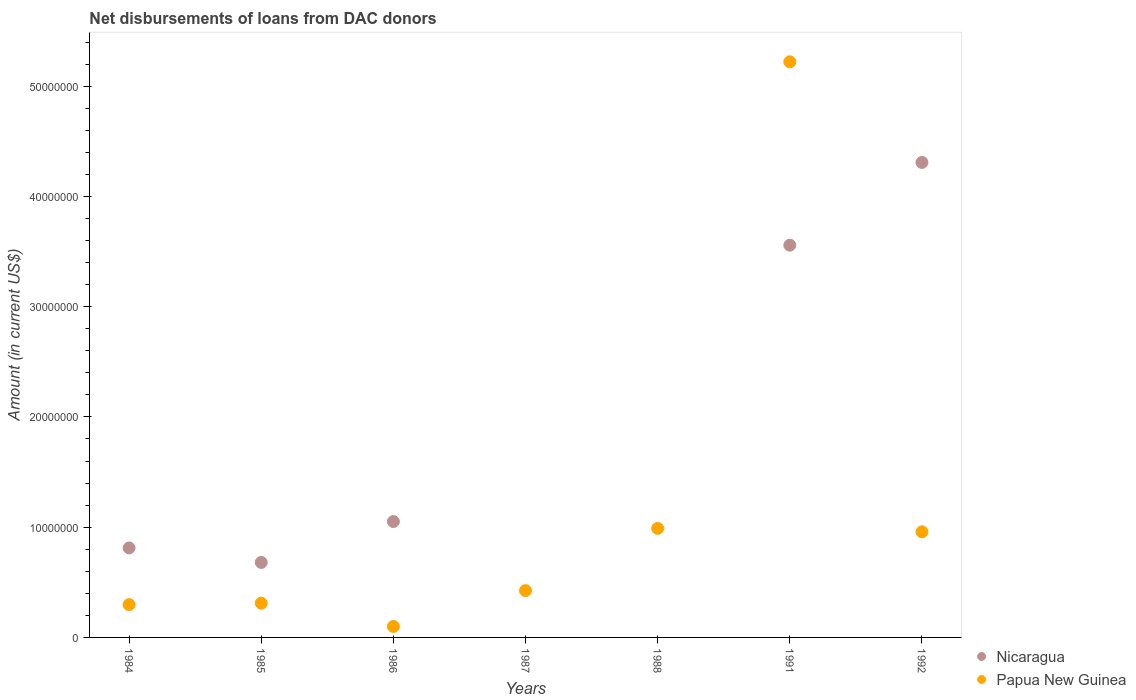What is the amount of loans disbursed in Nicaragua in 1992?
Your response must be concise. 4.31e+07. Across all years, what is the maximum amount of loans disbursed in Papua New Guinea?
Make the answer very short. 5.22e+07. Across all years, what is the minimum amount of loans disbursed in Papua New Guinea?
Make the answer very short. 9.99e+05. What is the total amount of loans disbursed in Papua New Guinea in the graph?
Your answer should be very brief. 8.30e+07. What is the difference between the amount of loans disbursed in Papua New Guinea in 1984 and that in 1987?
Give a very brief answer. -1.27e+06. What is the difference between the amount of loans disbursed in Nicaragua in 1988 and the amount of loans disbursed in Papua New Guinea in 1992?
Provide a short and direct response. -9.58e+06. What is the average amount of loans disbursed in Papua New Guinea per year?
Provide a succinct answer. 1.19e+07. In the year 1992, what is the difference between the amount of loans disbursed in Papua New Guinea and amount of loans disbursed in Nicaragua?
Your response must be concise. -3.35e+07. In how many years, is the amount of loans disbursed in Nicaragua greater than 12000000 US$?
Your answer should be compact. 2. What is the ratio of the amount of loans disbursed in Nicaragua in 1986 to that in 1992?
Make the answer very short. 0.24. Is the amount of loans disbursed in Papua New Guinea in 1991 less than that in 1992?
Give a very brief answer. No. What is the difference between the highest and the second highest amount of loans disbursed in Papua New Guinea?
Your answer should be compact. 4.23e+07. What is the difference between the highest and the lowest amount of loans disbursed in Nicaragua?
Give a very brief answer. 4.31e+07. Is the sum of the amount of loans disbursed in Nicaragua in 1991 and 1992 greater than the maximum amount of loans disbursed in Papua New Guinea across all years?
Provide a short and direct response. Yes. Is the amount of loans disbursed in Nicaragua strictly greater than the amount of loans disbursed in Papua New Guinea over the years?
Your answer should be compact. No. Is the amount of loans disbursed in Papua New Guinea strictly less than the amount of loans disbursed in Nicaragua over the years?
Your response must be concise. No. How many dotlines are there?
Keep it short and to the point. 2. How many years are there in the graph?
Offer a terse response. 7. What is the difference between two consecutive major ticks on the Y-axis?
Offer a very short reply. 1.00e+07. Are the values on the major ticks of Y-axis written in scientific E-notation?
Offer a terse response. No. Does the graph contain any zero values?
Make the answer very short. Yes. Does the graph contain grids?
Make the answer very short. No. Where does the legend appear in the graph?
Provide a succinct answer. Bottom right. What is the title of the graph?
Provide a short and direct response. Net disbursements of loans from DAC donors. What is the label or title of the X-axis?
Offer a terse response. Years. What is the label or title of the Y-axis?
Offer a very short reply. Amount (in current US$). What is the Amount (in current US$) of Nicaragua in 1984?
Provide a short and direct response. 8.12e+06. What is the Amount (in current US$) of Papua New Guinea in 1984?
Give a very brief answer. 2.98e+06. What is the Amount (in current US$) of Nicaragua in 1985?
Offer a terse response. 6.80e+06. What is the Amount (in current US$) of Papua New Guinea in 1985?
Offer a terse response. 3.10e+06. What is the Amount (in current US$) in Nicaragua in 1986?
Your response must be concise. 1.05e+07. What is the Amount (in current US$) of Papua New Guinea in 1986?
Ensure brevity in your answer.  9.99e+05. What is the Amount (in current US$) in Papua New Guinea in 1987?
Give a very brief answer. 4.24e+06. What is the Amount (in current US$) in Nicaragua in 1988?
Your response must be concise. 0. What is the Amount (in current US$) in Papua New Guinea in 1988?
Give a very brief answer. 9.89e+06. What is the Amount (in current US$) in Nicaragua in 1991?
Offer a terse response. 3.56e+07. What is the Amount (in current US$) of Papua New Guinea in 1991?
Make the answer very short. 5.22e+07. What is the Amount (in current US$) of Nicaragua in 1992?
Offer a terse response. 4.31e+07. What is the Amount (in current US$) of Papua New Guinea in 1992?
Offer a terse response. 9.58e+06. Across all years, what is the maximum Amount (in current US$) in Nicaragua?
Make the answer very short. 4.31e+07. Across all years, what is the maximum Amount (in current US$) of Papua New Guinea?
Keep it short and to the point. 5.22e+07. Across all years, what is the minimum Amount (in current US$) of Papua New Guinea?
Provide a short and direct response. 9.99e+05. What is the total Amount (in current US$) of Nicaragua in the graph?
Give a very brief answer. 1.04e+08. What is the total Amount (in current US$) in Papua New Guinea in the graph?
Keep it short and to the point. 8.30e+07. What is the difference between the Amount (in current US$) of Nicaragua in 1984 and that in 1985?
Give a very brief answer. 1.31e+06. What is the difference between the Amount (in current US$) of Nicaragua in 1984 and that in 1986?
Offer a very short reply. -2.39e+06. What is the difference between the Amount (in current US$) of Papua New Guinea in 1984 and that in 1986?
Give a very brief answer. 1.98e+06. What is the difference between the Amount (in current US$) in Papua New Guinea in 1984 and that in 1987?
Give a very brief answer. -1.27e+06. What is the difference between the Amount (in current US$) in Papua New Guinea in 1984 and that in 1988?
Your answer should be compact. -6.92e+06. What is the difference between the Amount (in current US$) of Nicaragua in 1984 and that in 1991?
Offer a very short reply. -2.75e+07. What is the difference between the Amount (in current US$) in Papua New Guinea in 1984 and that in 1991?
Ensure brevity in your answer.  -4.92e+07. What is the difference between the Amount (in current US$) of Nicaragua in 1984 and that in 1992?
Offer a very short reply. -3.50e+07. What is the difference between the Amount (in current US$) of Papua New Guinea in 1984 and that in 1992?
Offer a terse response. -6.60e+06. What is the difference between the Amount (in current US$) in Nicaragua in 1985 and that in 1986?
Your answer should be compact. -3.71e+06. What is the difference between the Amount (in current US$) in Papua New Guinea in 1985 and that in 1986?
Ensure brevity in your answer.  2.11e+06. What is the difference between the Amount (in current US$) in Papua New Guinea in 1985 and that in 1987?
Offer a very short reply. -1.14e+06. What is the difference between the Amount (in current US$) in Papua New Guinea in 1985 and that in 1988?
Your answer should be very brief. -6.79e+06. What is the difference between the Amount (in current US$) of Nicaragua in 1985 and that in 1991?
Your answer should be very brief. -2.88e+07. What is the difference between the Amount (in current US$) in Papua New Guinea in 1985 and that in 1991?
Keep it short and to the point. -4.91e+07. What is the difference between the Amount (in current US$) in Nicaragua in 1985 and that in 1992?
Offer a very short reply. -3.63e+07. What is the difference between the Amount (in current US$) of Papua New Guinea in 1985 and that in 1992?
Make the answer very short. -6.47e+06. What is the difference between the Amount (in current US$) of Papua New Guinea in 1986 and that in 1987?
Offer a terse response. -3.24e+06. What is the difference between the Amount (in current US$) in Papua New Guinea in 1986 and that in 1988?
Make the answer very short. -8.89e+06. What is the difference between the Amount (in current US$) in Nicaragua in 1986 and that in 1991?
Keep it short and to the point. -2.51e+07. What is the difference between the Amount (in current US$) of Papua New Guinea in 1986 and that in 1991?
Provide a succinct answer. -5.12e+07. What is the difference between the Amount (in current US$) in Nicaragua in 1986 and that in 1992?
Provide a short and direct response. -3.26e+07. What is the difference between the Amount (in current US$) in Papua New Guinea in 1986 and that in 1992?
Make the answer very short. -8.58e+06. What is the difference between the Amount (in current US$) in Papua New Guinea in 1987 and that in 1988?
Give a very brief answer. -5.65e+06. What is the difference between the Amount (in current US$) in Papua New Guinea in 1987 and that in 1991?
Keep it short and to the point. -4.80e+07. What is the difference between the Amount (in current US$) of Papua New Guinea in 1987 and that in 1992?
Ensure brevity in your answer.  -5.33e+06. What is the difference between the Amount (in current US$) in Papua New Guinea in 1988 and that in 1991?
Your answer should be very brief. -4.23e+07. What is the difference between the Amount (in current US$) of Papua New Guinea in 1988 and that in 1992?
Your answer should be compact. 3.13e+05. What is the difference between the Amount (in current US$) of Nicaragua in 1991 and that in 1992?
Offer a terse response. -7.50e+06. What is the difference between the Amount (in current US$) in Papua New Guinea in 1991 and that in 1992?
Your response must be concise. 4.26e+07. What is the difference between the Amount (in current US$) of Nicaragua in 1984 and the Amount (in current US$) of Papua New Guinea in 1985?
Offer a very short reply. 5.01e+06. What is the difference between the Amount (in current US$) in Nicaragua in 1984 and the Amount (in current US$) in Papua New Guinea in 1986?
Give a very brief answer. 7.12e+06. What is the difference between the Amount (in current US$) in Nicaragua in 1984 and the Amount (in current US$) in Papua New Guinea in 1987?
Offer a very short reply. 3.87e+06. What is the difference between the Amount (in current US$) of Nicaragua in 1984 and the Amount (in current US$) of Papua New Guinea in 1988?
Provide a short and direct response. -1.78e+06. What is the difference between the Amount (in current US$) of Nicaragua in 1984 and the Amount (in current US$) of Papua New Guinea in 1991?
Offer a terse response. -4.41e+07. What is the difference between the Amount (in current US$) in Nicaragua in 1984 and the Amount (in current US$) in Papua New Guinea in 1992?
Your answer should be compact. -1.46e+06. What is the difference between the Amount (in current US$) of Nicaragua in 1985 and the Amount (in current US$) of Papua New Guinea in 1986?
Your answer should be compact. 5.80e+06. What is the difference between the Amount (in current US$) of Nicaragua in 1985 and the Amount (in current US$) of Papua New Guinea in 1987?
Provide a short and direct response. 2.56e+06. What is the difference between the Amount (in current US$) of Nicaragua in 1985 and the Amount (in current US$) of Papua New Guinea in 1988?
Provide a short and direct response. -3.09e+06. What is the difference between the Amount (in current US$) in Nicaragua in 1985 and the Amount (in current US$) in Papua New Guinea in 1991?
Ensure brevity in your answer.  -4.54e+07. What is the difference between the Amount (in current US$) in Nicaragua in 1985 and the Amount (in current US$) in Papua New Guinea in 1992?
Offer a terse response. -2.78e+06. What is the difference between the Amount (in current US$) in Nicaragua in 1986 and the Amount (in current US$) in Papua New Guinea in 1987?
Provide a succinct answer. 6.27e+06. What is the difference between the Amount (in current US$) in Nicaragua in 1986 and the Amount (in current US$) in Papua New Guinea in 1988?
Provide a succinct answer. 6.19e+05. What is the difference between the Amount (in current US$) in Nicaragua in 1986 and the Amount (in current US$) in Papua New Guinea in 1991?
Your response must be concise. -4.17e+07. What is the difference between the Amount (in current US$) of Nicaragua in 1986 and the Amount (in current US$) of Papua New Guinea in 1992?
Offer a terse response. 9.32e+05. What is the difference between the Amount (in current US$) in Nicaragua in 1991 and the Amount (in current US$) in Papua New Guinea in 1992?
Make the answer very short. 2.60e+07. What is the average Amount (in current US$) of Nicaragua per year?
Keep it short and to the point. 1.49e+07. What is the average Amount (in current US$) of Papua New Guinea per year?
Your response must be concise. 1.19e+07. In the year 1984, what is the difference between the Amount (in current US$) of Nicaragua and Amount (in current US$) of Papua New Guinea?
Offer a terse response. 5.14e+06. In the year 1985, what is the difference between the Amount (in current US$) of Nicaragua and Amount (in current US$) of Papua New Guinea?
Your response must be concise. 3.70e+06. In the year 1986, what is the difference between the Amount (in current US$) of Nicaragua and Amount (in current US$) of Papua New Guinea?
Your answer should be very brief. 9.51e+06. In the year 1991, what is the difference between the Amount (in current US$) of Nicaragua and Amount (in current US$) of Papua New Guinea?
Your answer should be compact. -1.66e+07. In the year 1992, what is the difference between the Amount (in current US$) of Nicaragua and Amount (in current US$) of Papua New Guinea?
Ensure brevity in your answer.  3.35e+07. What is the ratio of the Amount (in current US$) of Nicaragua in 1984 to that in 1985?
Ensure brevity in your answer.  1.19. What is the ratio of the Amount (in current US$) in Papua New Guinea in 1984 to that in 1985?
Ensure brevity in your answer.  0.96. What is the ratio of the Amount (in current US$) of Nicaragua in 1984 to that in 1986?
Your answer should be compact. 0.77. What is the ratio of the Amount (in current US$) of Papua New Guinea in 1984 to that in 1986?
Offer a very short reply. 2.98. What is the ratio of the Amount (in current US$) of Papua New Guinea in 1984 to that in 1987?
Provide a short and direct response. 0.7. What is the ratio of the Amount (in current US$) in Papua New Guinea in 1984 to that in 1988?
Offer a very short reply. 0.3. What is the ratio of the Amount (in current US$) in Nicaragua in 1984 to that in 1991?
Keep it short and to the point. 0.23. What is the ratio of the Amount (in current US$) of Papua New Guinea in 1984 to that in 1991?
Your response must be concise. 0.06. What is the ratio of the Amount (in current US$) in Nicaragua in 1984 to that in 1992?
Offer a terse response. 0.19. What is the ratio of the Amount (in current US$) of Papua New Guinea in 1984 to that in 1992?
Offer a very short reply. 0.31. What is the ratio of the Amount (in current US$) of Nicaragua in 1985 to that in 1986?
Ensure brevity in your answer.  0.65. What is the ratio of the Amount (in current US$) of Papua New Guinea in 1985 to that in 1986?
Your answer should be very brief. 3.11. What is the ratio of the Amount (in current US$) in Papua New Guinea in 1985 to that in 1987?
Your response must be concise. 0.73. What is the ratio of the Amount (in current US$) in Papua New Guinea in 1985 to that in 1988?
Ensure brevity in your answer.  0.31. What is the ratio of the Amount (in current US$) in Nicaragua in 1985 to that in 1991?
Offer a very short reply. 0.19. What is the ratio of the Amount (in current US$) of Papua New Guinea in 1985 to that in 1991?
Offer a terse response. 0.06. What is the ratio of the Amount (in current US$) in Nicaragua in 1985 to that in 1992?
Offer a terse response. 0.16. What is the ratio of the Amount (in current US$) in Papua New Guinea in 1985 to that in 1992?
Ensure brevity in your answer.  0.32. What is the ratio of the Amount (in current US$) in Papua New Guinea in 1986 to that in 1987?
Your answer should be very brief. 0.24. What is the ratio of the Amount (in current US$) in Papua New Guinea in 1986 to that in 1988?
Provide a succinct answer. 0.1. What is the ratio of the Amount (in current US$) of Nicaragua in 1986 to that in 1991?
Provide a succinct answer. 0.3. What is the ratio of the Amount (in current US$) of Papua New Guinea in 1986 to that in 1991?
Your answer should be compact. 0.02. What is the ratio of the Amount (in current US$) of Nicaragua in 1986 to that in 1992?
Ensure brevity in your answer.  0.24. What is the ratio of the Amount (in current US$) in Papua New Guinea in 1986 to that in 1992?
Your response must be concise. 0.1. What is the ratio of the Amount (in current US$) in Papua New Guinea in 1987 to that in 1988?
Give a very brief answer. 0.43. What is the ratio of the Amount (in current US$) of Papua New Guinea in 1987 to that in 1991?
Offer a terse response. 0.08. What is the ratio of the Amount (in current US$) in Papua New Guinea in 1987 to that in 1992?
Your answer should be compact. 0.44. What is the ratio of the Amount (in current US$) of Papua New Guinea in 1988 to that in 1991?
Your answer should be very brief. 0.19. What is the ratio of the Amount (in current US$) in Papua New Guinea in 1988 to that in 1992?
Make the answer very short. 1.03. What is the ratio of the Amount (in current US$) of Nicaragua in 1991 to that in 1992?
Provide a succinct answer. 0.83. What is the ratio of the Amount (in current US$) of Papua New Guinea in 1991 to that in 1992?
Provide a short and direct response. 5.45. What is the difference between the highest and the second highest Amount (in current US$) in Nicaragua?
Provide a succinct answer. 7.50e+06. What is the difference between the highest and the second highest Amount (in current US$) in Papua New Guinea?
Offer a very short reply. 4.23e+07. What is the difference between the highest and the lowest Amount (in current US$) in Nicaragua?
Give a very brief answer. 4.31e+07. What is the difference between the highest and the lowest Amount (in current US$) of Papua New Guinea?
Offer a very short reply. 5.12e+07. 